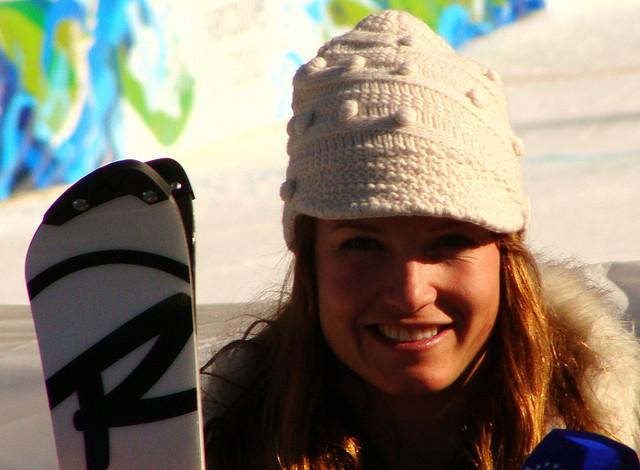What letter is on the board?
Concise answer only. R. Is the woman wearing something on her head?
Answer briefly. Yes. What color is the woman's hat?
Short answer required. White. 